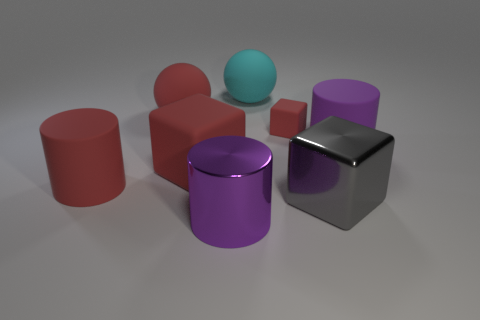Subtract all large blocks. How many blocks are left? 1 Subtract all brown balls. How many purple cylinders are left? 2 Subtract 1 blocks. How many blocks are left? 2 Add 2 blue metallic objects. How many objects exist? 10 Subtract all yellow cylinders. Subtract all blue blocks. How many cylinders are left? 3 Subtract all balls. How many objects are left? 6 Add 2 red cylinders. How many red cylinders are left? 3 Add 2 brown cubes. How many brown cubes exist? 2 Subtract 0 yellow cylinders. How many objects are left? 8 Subtract all big cyan rubber balls. Subtract all big rubber things. How many objects are left? 2 